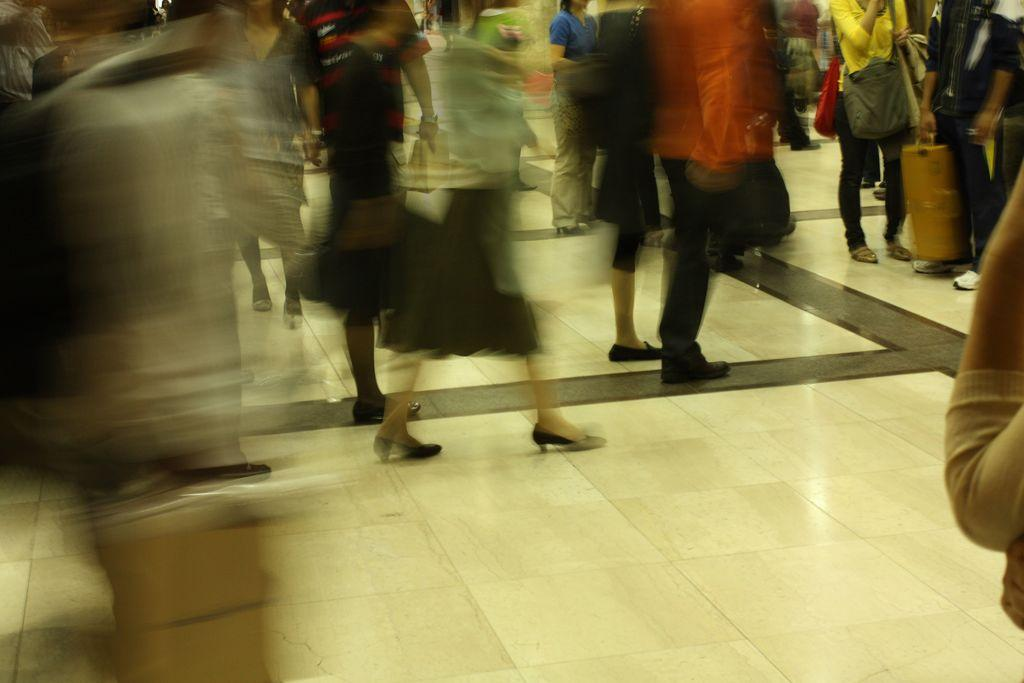What is the main subject of the image? The main subject of the image is a crowd. How are the people in the crowd positioned? The people in the crowd are standing on the floor. What are some of the people in the crowd holding? Some of the people in the crowd are carrying bags in their hands. How does the company increase its profits in the image? There is no mention of a company or profits in the image; it features a crowd of people standing on the floor. What type of poison is being used by the people in the image? There is no mention of poison or any dangerous substances in the image; it features a crowd of people standing on the floor. 